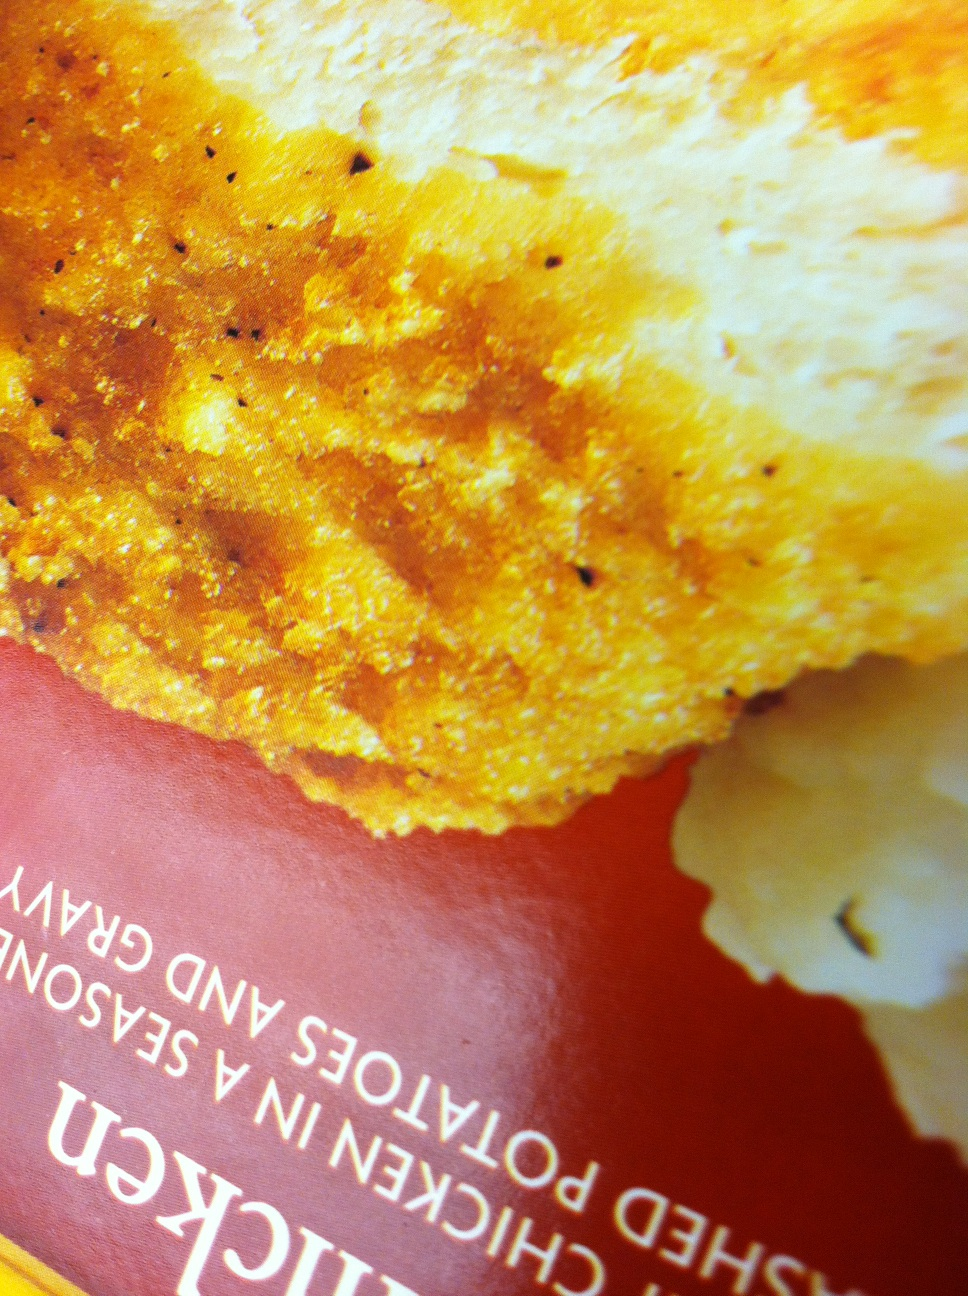What could be a suitable drink to accompany this meal? A suitable drink to pair with this crispy chicken and mashed potatoes meal could be a light, sparkling beverage, such as soda or sparkling water, to balance the richness of the gravy. And what about a healthier drink option? For a healthier option, an unsweetened iced tea or a lemon water would complement the meal without adding extra calories. 